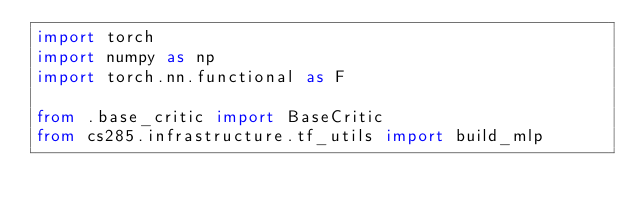<code> <loc_0><loc_0><loc_500><loc_500><_Python_>import torch
import numpy as np
import torch.nn.functional as F

from .base_critic import BaseCritic
from cs285.infrastructure.tf_utils import build_mlp</code> 